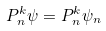Convert formula to latex. <formula><loc_0><loc_0><loc_500><loc_500>P _ { n } ^ { k } \psi = P _ { n } ^ { k } \psi _ { n }</formula> 